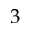Convert formula to latex. <formula><loc_0><loc_0><loc_500><loc_500>3</formula> 